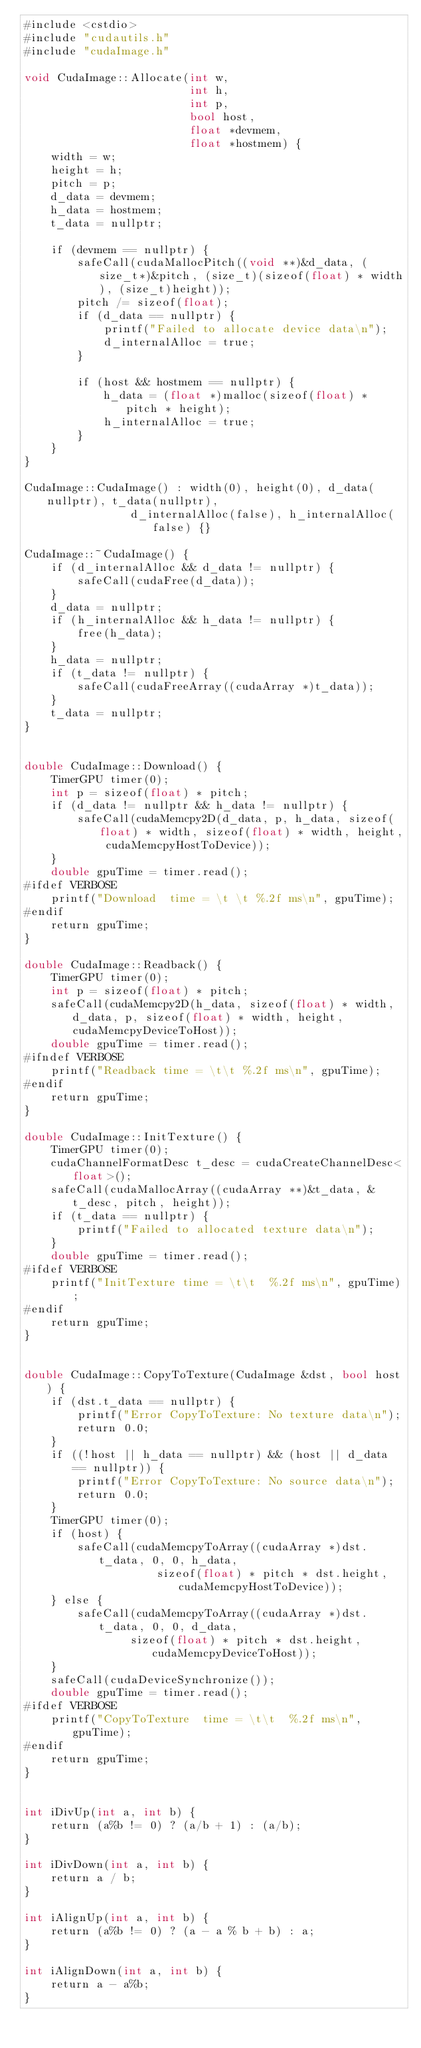<code> <loc_0><loc_0><loc_500><loc_500><_Cuda_>#include <cstdio>
#include "cudautils.h"
#include "cudaImage.h"

void CudaImage::Allocate(int w, 
                         int h, 
                         int p, 
                         bool host, 
                         float *devmem, 
                         float *hostmem) {
    width = w;
    height = h;
    pitch = p;
    d_data = devmem;
    h_data = hostmem;
    t_data = nullptr;

    if (devmem == nullptr) {
        safeCall(cudaMallocPitch((void **)&d_data, (size_t*)&pitch, (size_t)(sizeof(float) * width), (size_t)height));
        pitch /= sizeof(float);
        if (d_data == nullptr) {
            printf("Failed to allocate device data\n");
            d_internalAlloc = true;
        }

        if (host && hostmem == nullptr) {
            h_data = (float *)malloc(sizeof(float) * pitch * height);
            h_internalAlloc = true;
        }
    }
}

CudaImage::CudaImage() : width(0), height(0), d_data(nullptr), t_data(nullptr), 
                d_internalAlloc(false), h_internalAlloc(false) {}

CudaImage::~CudaImage() {
    if (d_internalAlloc && d_data != nullptr) {
        safeCall(cudaFree(d_data));
    }
    d_data = nullptr;
    if (h_internalAlloc && h_data != nullptr) {
        free(h_data);
    }
    h_data = nullptr;
    if (t_data != nullptr) {
        safeCall(cudaFreeArray((cudaArray *)t_data));
    }
    t_data = nullptr;
}


double CudaImage::Download() {
    TimerGPU timer(0);
    int p = sizeof(float) * pitch;
    if (d_data != nullptr && h_data != nullptr) {
        safeCall(cudaMemcpy2D(d_data, p, h_data, sizeof(float) * width, sizeof(float) * width, height, cudaMemcpyHostToDevice));
    }
    double gpuTime = timer.read();
#ifdef VERBOSE
    printf("Download  time = \t \t %.2f ms\n", gpuTime);
#endif
    return gpuTime;
}

double CudaImage::Readback() {
    TimerGPU timer(0);
    int p = sizeof(float) * pitch;
    safeCall(cudaMemcpy2D(h_data, sizeof(float) * width, d_data, p, sizeof(float) * width, height, cudaMemcpyDeviceToHost));
    double gpuTime = timer.read();
#ifndef VERBOSE
    printf("Readback time = \t\t %.2f ms\n", gpuTime);
#endif
    return gpuTime;
}

double CudaImage::InitTexture() {
    TimerGPU timer(0);
    cudaChannelFormatDesc t_desc = cudaCreateChannelDesc<float>();
    safeCall(cudaMallocArray((cudaArray **)&t_data, &t_desc, pitch, height));
    if (t_data == nullptr) {
        printf("Failed to allocated texture data\n");
    }
    double gpuTime = timer.read();
#ifdef VERBOSE
    printf("InitTexture time = \t\t  %.2f ms\n", gpuTime);
#endif
    return gpuTime;
}


double CudaImage::CopyToTexture(CudaImage &dst, bool host) {
    if (dst.t_data == nullptr) {
        printf("Error CopyToTexture: No texture data\n");
        return 0.0;
    }
    if ((!host || h_data == nullptr) && (host || d_data == nullptr)) {
        printf("Error CopyToTexture: No source data\n");
        return 0.0;
    }
    TimerGPU timer(0);
    if (host) {
        safeCall(cudaMemcpyToArray((cudaArray *)dst.t_data, 0, 0, h_data, 
                    sizeof(float) * pitch * dst.height, cudaMemcpyHostToDevice));
    } else {
        safeCall(cudaMemcpyToArray((cudaArray *)dst.t_data, 0, 0, d_data,
                sizeof(float) * pitch * dst.height, cudaMemcpyDeviceToHost));
    }
    safeCall(cudaDeviceSynchronize());
    double gpuTime = timer.read();
#ifdef VERBOSE
    printf("CopyToTexture  time = \t\t  %.2f ms\n", gpuTime);
#endif
    return gpuTime;
}


int iDivUp(int a, int b) {
    return (a%b != 0) ? (a/b + 1) : (a/b);
}

int iDivDown(int a, int b) {
    return a / b;
}

int iAlignUp(int a, int b) {
    return (a%b != 0) ? (a - a % b + b) : a;
}

int iAlignDown(int a, int b) {
    return a - a%b;
}

</code> 